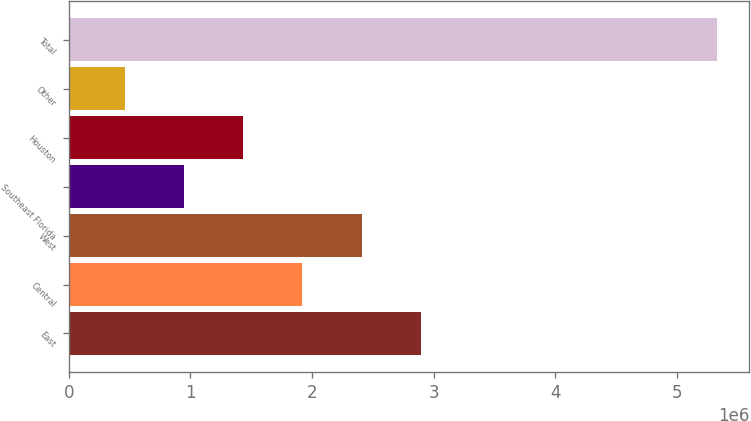<chart> <loc_0><loc_0><loc_500><loc_500><bar_chart><fcel>East<fcel>Central<fcel>West<fcel>Southeast Florida<fcel>Houston<fcel>Other<fcel>Total<nl><fcel>2.8938e+06<fcel>1.92018e+06<fcel>2.40699e+06<fcel>946555<fcel>1.43337e+06<fcel>459743<fcel>5.32787e+06<nl></chart> 